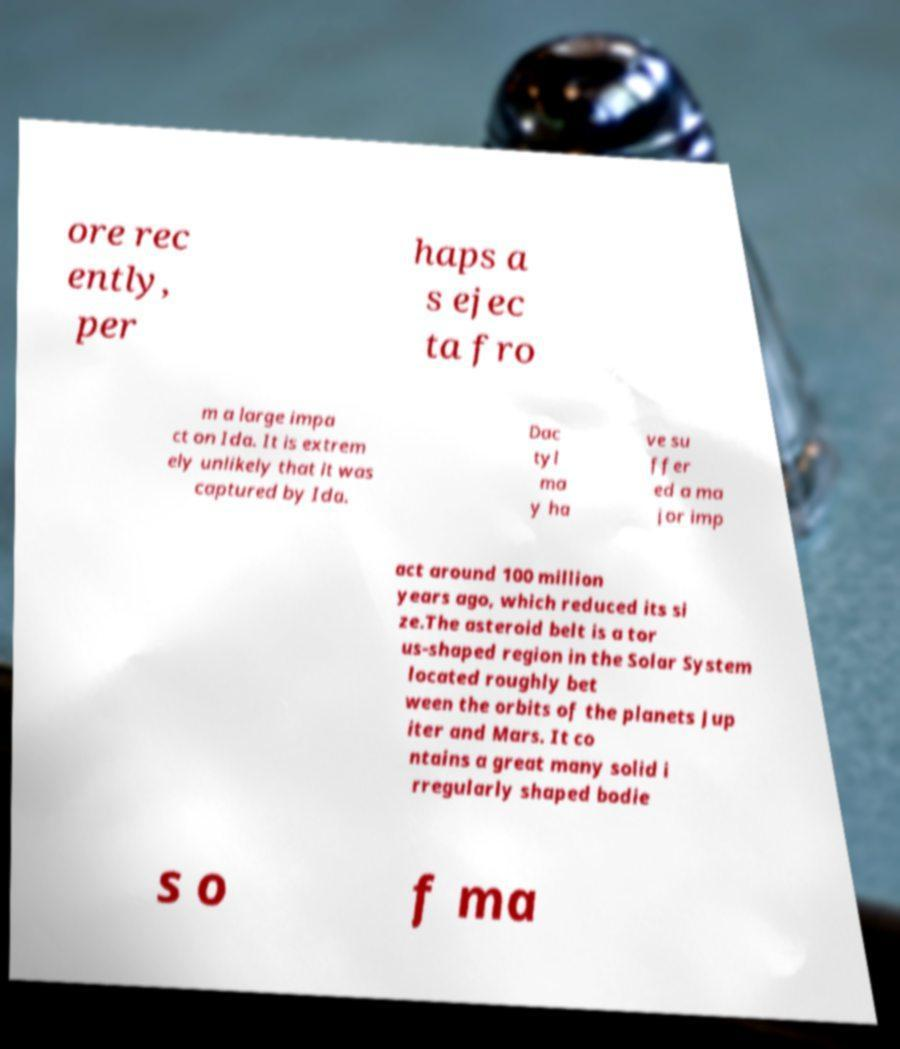Can you accurately transcribe the text from the provided image for me? ore rec ently, per haps a s ejec ta fro m a large impa ct on Ida. It is extrem ely unlikely that it was captured by Ida. Dac tyl ma y ha ve su ffer ed a ma jor imp act around 100 million years ago, which reduced its si ze.The asteroid belt is a tor us-shaped region in the Solar System located roughly bet ween the orbits of the planets Jup iter and Mars. It co ntains a great many solid i rregularly shaped bodie s o f ma 